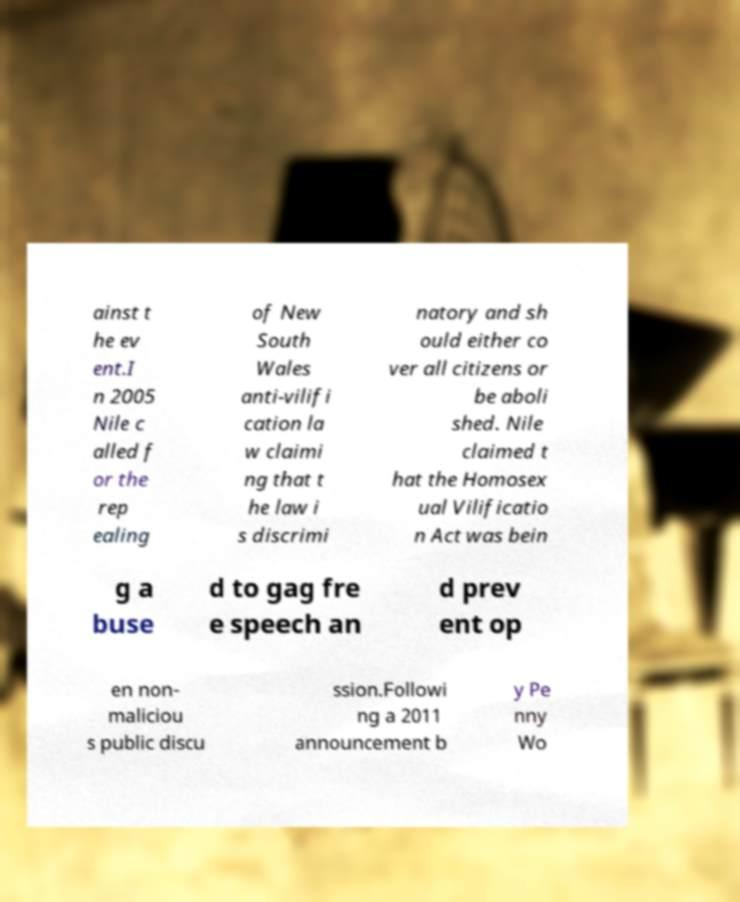What messages or text are displayed in this image? I need them in a readable, typed format. ainst t he ev ent.I n 2005 Nile c alled f or the rep ealing of New South Wales anti-vilifi cation la w claimi ng that t he law i s discrimi natory and sh ould either co ver all citizens or be aboli shed. Nile claimed t hat the Homosex ual Vilificatio n Act was bein g a buse d to gag fre e speech an d prev ent op en non- maliciou s public discu ssion.Followi ng a 2011 announcement b y Pe nny Wo 